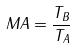Convert formula to latex. <formula><loc_0><loc_0><loc_500><loc_500>M A = \frac { T _ { B } } { T _ { A } }</formula> 